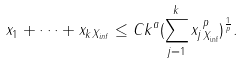Convert formula to latex. <formula><loc_0><loc_0><loc_500><loc_500>\| x _ { 1 } + \cdots + x _ { k } \| _ { X _ { i n f } } \leq C k ^ { a } ( \sum _ { j = 1 } ^ { k } \| x _ { j } \| _ { X _ { \inf } } ^ { p } ) ^ { \frac { 1 } { p } } .</formula> 